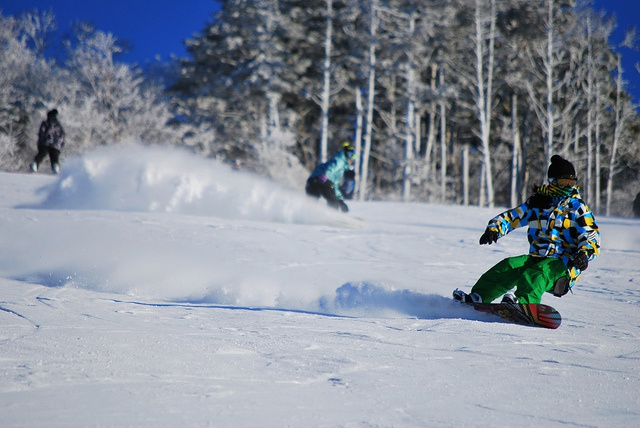Describe the objects in this image and their specific colors. I can see people in darkblue, black, darkgreen, navy, and blue tones, people in darkblue, black, navy, teal, and gray tones, people in darkblue, black, and gray tones, and snowboard in darkblue, black, maroon, blue, and navy tones in this image. 